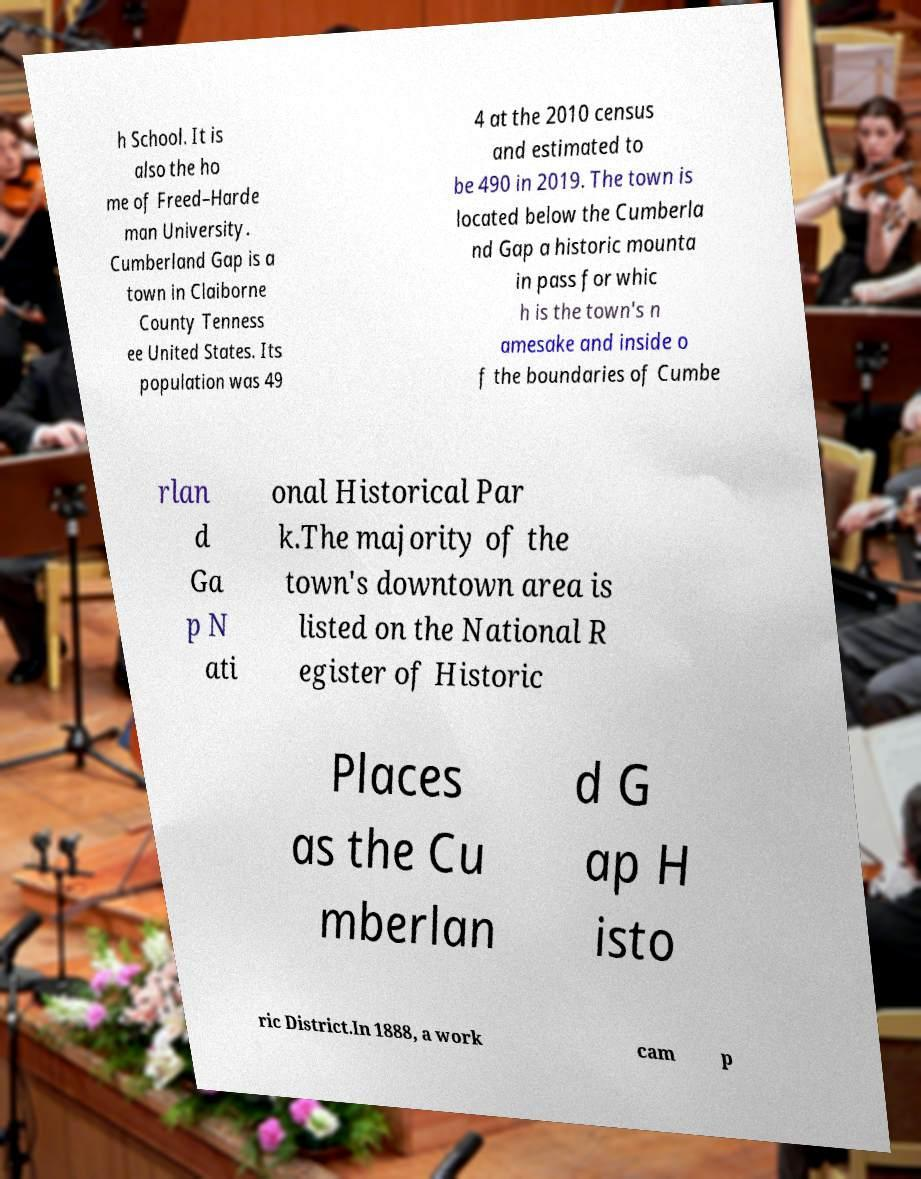Can you accurately transcribe the text from the provided image for me? h School. It is also the ho me of Freed–Harde man University. Cumberland Gap is a town in Claiborne County Tenness ee United States. Its population was 49 4 at the 2010 census and estimated to be 490 in 2019. The town is located below the Cumberla nd Gap a historic mounta in pass for whic h is the town's n amesake and inside o f the boundaries of Cumbe rlan d Ga p N ati onal Historical Par k.The majority of the town's downtown area is listed on the National R egister of Historic Places as the Cu mberlan d G ap H isto ric District.In 1888, a work cam p 